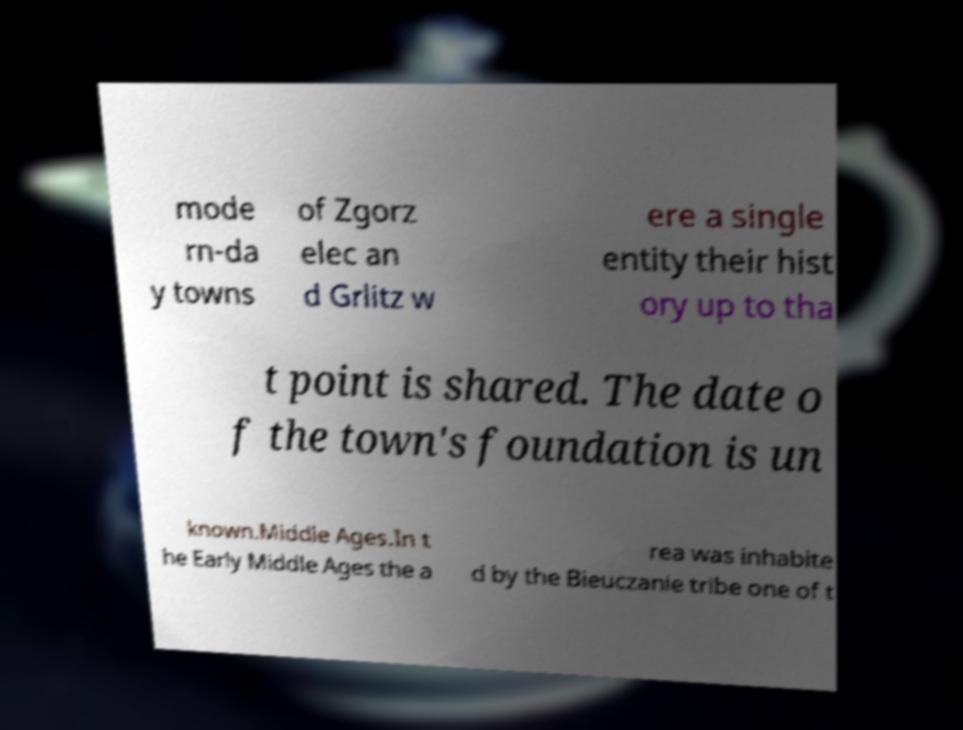What messages or text are displayed in this image? I need them in a readable, typed format. mode rn-da y towns of Zgorz elec an d Grlitz w ere a single entity their hist ory up to tha t point is shared. The date o f the town's foundation is un known.Middle Ages.In t he Early Middle Ages the a rea was inhabite d by the Bieuczanie tribe one of t 